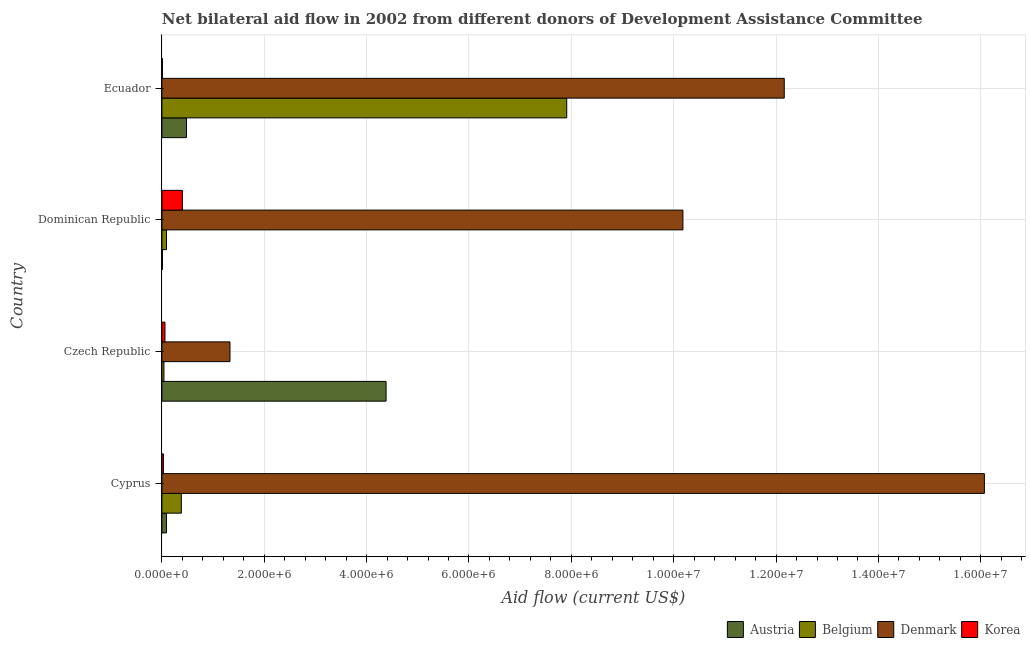How many groups of bars are there?
Provide a succinct answer. 4. Are the number of bars per tick equal to the number of legend labels?
Make the answer very short. Yes. How many bars are there on the 1st tick from the top?
Offer a very short reply. 4. What is the label of the 2nd group of bars from the top?
Make the answer very short. Dominican Republic. In how many cases, is the number of bars for a given country not equal to the number of legend labels?
Ensure brevity in your answer.  0. What is the amount of aid given by korea in Dominican Republic?
Your response must be concise. 4.00e+05. Across all countries, what is the maximum amount of aid given by korea?
Your answer should be very brief. 4.00e+05. Across all countries, what is the minimum amount of aid given by denmark?
Your answer should be compact. 1.33e+06. In which country was the amount of aid given by belgium maximum?
Your answer should be compact. Ecuador. In which country was the amount of aid given by belgium minimum?
Offer a terse response. Czech Republic. What is the total amount of aid given by austria in the graph?
Provide a short and direct response. 4.96e+06. What is the difference between the amount of aid given by korea in Cyprus and that in Czech Republic?
Offer a terse response. -3.00e+04. What is the difference between the amount of aid given by korea in Ecuador and the amount of aid given by austria in Cyprus?
Your answer should be compact. -8.00e+04. What is the average amount of aid given by korea per country?
Ensure brevity in your answer.  1.25e+05. What is the difference between the amount of aid given by korea and amount of aid given by denmark in Czech Republic?
Provide a short and direct response. -1.27e+06. In how many countries, is the amount of aid given by belgium greater than 800000 US$?
Your answer should be compact. 1. What is the ratio of the amount of aid given by denmark in Cyprus to that in Dominican Republic?
Give a very brief answer. 1.58. Is the amount of aid given by denmark in Czech Republic less than that in Dominican Republic?
Give a very brief answer. Yes. Is the difference between the amount of aid given by korea in Dominican Republic and Ecuador greater than the difference between the amount of aid given by denmark in Dominican Republic and Ecuador?
Offer a terse response. Yes. What is the difference between the highest and the second highest amount of aid given by korea?
Your answer should be very brief. 3.40e+05. What is the difference between the highest and the lowest amount of aid given by austria?
Offer a very short reply. 4.37e+06. In how many countries, is the amount of aid given by austria greater than the average amount of aid given by austria taken over all countries?
Make the answer very short. 1. What does the 1st bar from the bottom in Dominican Republic represents?
Your response must be concise. Austria. How many bars are there?
Your response must be concise. 16. How many countries are there in the graph?
Provide a succinct answer. 4. Are the values on the major ticks of X-axis written in scientific E-notation?
Provide a succinct answer. Yes. Does the graph contain grids?
Provide a succinct answer. Yes. How many legend labels are there?
Ensure brevity in your answer.  4. What is the title of the graph?
Your response must be concise. Net bilateral aid flow in 2002 from different donors of Development Assistance Committee. Does "International Development Association" appear as one of the legend labels in the graph?
Your response must be concise. No. What is the Aid flow (current US$) in Austria in Cyprus?
Give a very brief answer. 9.00e+04. What is the Aid flow (current US$) in Denmark in Cyprus?
Your answer should be very brief. 1.61e+07. What is the Aid flow (current US$) in Austria in Czech Republic?
Your answer should be very brief. 4.38e+06. What is the Aid flow (current US$) of Belgium in Czech Republic?
Offer a very short reply. 4.00e+04. What is the Aid flow (current US$) in Denmark in Czech Republic?
Provide a short and direct response. 1.33e+06. What is the Aid flow (current US$) of Belgium in Dominican Republic?
Make the answer very short. 9.00e+04. What is the Aid flow (current US$) of Denmark in Dominican Republic?
Provide a short and direct response. 1.02e+07. What is the Aid flow (current US$) of Korea in Dominican Republic?
Give a very brief answer. 4.00e+05. What is the Aid flow (current US$) of Austria in Ecuador?
Give a very brief answer. 4.80e+05. What is the Aid flow (current US$) in Belgium in Ecuador?
Give a very brief answer. 7.91e+06. What is the Aid flow (current US$) in Denmark in Ecuador?
Offer a very short reply. 1.22e+07. Across all countries, what is the maximum Aid flow (current US$) in Austria?
Your response must be concise. 4.38e+06. Across all countries, what is the maximum Aid flow (current US$) in Belgium?
Provide a succinct answer. 7.91e+06. Across all countries, what is the maximum Aid flow (current US$) in Denmark?
Provide a short and direct response. 1.61e+07. Across all countries, what is the minimum Aid flow (current US$) in Austria?
Your answer should be very brief. 10000. Across all countries, what is the minimum Aid flow (current US$) of Belgium?
Your answer should be very brief. 4.00e+04. Across all countries, what is the minimum Aid flow (current US$) of Denmark?
Provide a short and direct response. 1.33e+06. What is the total Aid flow (current US$) in Austria in the graph?
Your answer should be very brief. 4.96e+06. What is the total Aid flow (current US$) in Belgium in the graph?
Provide a succinct answer. 8.42e+06. What is the total Aid flow (current US$) in Denmark in the graph?
Offer a terse response. 3.97e+07. What is the difference between the Aid flow (current US$) in Austria in Cyprus and that in Czech Republic?
Provide a short and direct response. -4.29e+06. What is the difference between the Aid flow (current US$) of Denmark in Cyprus and that in Czech Republic?
Keep it short and to the point. 1.47e+07. What is the difference between the Aid flow (current US$) of Korea in Cyprus and that in Czech Republic?
Your answer should be compact. -3.00e+04. What is the difference between the Aid flow (current US$) of Belgium in Cyprus and that in Dominican Republic?
Your answer should be very brief. 2.90e+05. What is the difference between the Aid flow (current US$) of Denmark in Cyprus and that in Dominican Republic?
Your response must be concise. 5.89e+06. What is the difference between the Aid flow (current US$) in Korea in Cyprus and that in Dominican Republic?
Give a very brief answer. -3.70e+05. What is the difference between the Aid flow (current US$) of Austria in Cyprus and that in Ecuador?
Offer a very short reply. -3.90e+05. What is the difference between the Aid flow (current US$) of Belgium in Cyprus and that in Ecuador?
Keep it short and to the point. -7.53e+06. What is the difference between the Aid flow (current US$) in Denmark in Cyprus and that in Ecuador?
Give a very brief answer. 3.91e+06. What is the difference between the Aid flow (current US$) in Korea in Cyprus and that in Ecuador?
Keep it short and to the point. 2.00e+04. What is the difference between the Aid flow (current US$) of Austria in Czech Republic and that in Dominican Republic?
Provide a succinct answer. 4.37e+06. What is the difference between the Aid flow (current US$) in Belgium in Czech Republic and that in Dominican Republic?
Provide a short and direct response. -5.00e+04. What is the difference between the Aid flow (current US$) in Denmark in Czech Republic and that in Dominican Republic?
Make the answer very short. -8.85e+06. What is the difference between the Aid flow (current US$) of Korea in Czech Republic and that in Dominican Republic?
Give a very brief answer. -3.40e+05. What is the difference between the Aid flow (current US$) in Austria in Czech Republic and that in Ecuador?
Your answer should be compact. 3.90e+06. What is the difference between the Aid flow (current US$) in Belgium in Czech Republic and that in Ecuador?
Provide a short and direct response. -7.87e+06. What is the difference between the Aid flow (current US$) of Denmark in Czech Republic and that in Ecuador?
Keep it short and to the point. -1.08e+07. What is the difference between the Aid flow (current US$) of Austria in Dominican Republic and that in Ecuador?
Your response must be concise. -4.70e+05. What is the difference between the Aid flow (current US$) of Belgium in Dominican Republic and that in Ecuador?
Your response must be concise. -7.82e+06. What is the difference between the Aid flow (current US$) in Denmark in Dominican Republic and that in Ecuador?
Keep it short and to the point. -1.98e+06. What is the difference between the Aid flow (current US$) in Austria in Cyprus and the Aid flow (current US$) in Denmark in Czech Republic?
Your answer should be very brief. -1.24e+06. What is the difference between the Aid flow (current US$) of Austria in Cyprus and the Aid flow (current US$) of Korea in Czech Republic?
Keep it short and to the point. 3.00e+04. What is the difference between the Aid flow (current US$) in Belgium in Cyprus and the Aid flow (current US$) in Denmark in Czech Republic?
Your answer should be compact. -9.50e+05. What is the difference between the Aid flow (current US$) of Belgium in Cyprus and the Aid flow (current US$) of Korea in Czech Republic?
Your answer should be very brief. 3.20e+05. What is the difference between the Aid flow (current US$) in Denmark in Cyprus and the Aid flow (current US$) in Korea in Czech Republic?
Provide a short and direct response. 1.60e+07. What is the difference between the Aid flow (current US$) in Austria in Cyprus and the Aid flow (current US$) in Belgium in Dominican Republic?
Make the answer very short. 0. What is the difference between the Aid flow (current US$) of Austria in Cyprus and the Aid flow (current US$) of Denmark in Dominican Republic?
Your answer should be very brief. -1.01e+07. What is the difference between the Aid flow (current US$) of Austria in Cyprus and the Aid flow (current US$) of Korea in Dominican Republic?
Offer a very short reply. -3.10e+05. What is the difference between the Aid flow (current US$) of Belgium in Cyprus and the Aid flow (current US$) of Denmark in Dominican Republic?
Ensure brevity in your answer.  -9.80e+06. What is the difference between the Aid flow (current US$) in Denmark in Cyprus and the Aid flow (current US$) in Korea in Dominican Republic?
Give a very brief answer. 1.57e+07. What is the difference between the Aid flow (current US$) of Austria in Cyprus and the Aid flow (current US$) of Belgium in Ecuador?
Provide a short and direct response. -7.82e+06. What is the difference between the Aid flow (current US$) in Austria in Cyprus and the Aid flow (current US$) in Denmark in Ecuador?
Ensure brevity in your answer.  -1.21e+07. What is the difference between the Aid flow (current US$) in Austria in Cyprus and the Aid flow (current US$) in Korea in Ecuador?
Ensure brevity in your answer.  8.00e+04. What is the difference between the Aid flow (current US$) in Belgium in Cyprus and the Aid flow (current US$) in Denmark in Ecuador?
Give a very brief answer. -1.18e+07. What is the difference between the Aid flow (current US$) of Belgium in Cyprus and the Aid flow (current US$) of Korea in Ecuador?
Offer a terse response. 3.70e+05. What is the difference between the Aid flow (current US$) in Denmark in Cyprus and the Aid flow (current US$) in Korea in Ecuador?
Provide a succinct answer. 1.61e+07. What is the difference between the Aid flow (current US$) of Austria in Czech Republic and the Aid flow (current US$) of Belgium in Dominican Republic?
Your response must be concise. 4.29e+06. What is the difference between the Aid flow (current US$) in Austria in Czech Republic and the Aid flow (current US$) in Denmark in Dominican Republic?
Give a very brief answer. -5.80e+06. What is the difference between the Aid flow (current US$) of Austria in Czech Republic and the Aid flow (current US$) of Korea in Dominican Republic?
Provide a short and direct response. 3.98e+06. What is the difference between the Aid flow (current US$) of Belgium in Czech Republic and the Aid flow (current US$) of Denmark in Dominican Republic?
Make the answer very short. -1.01e+07. What is the difference between the Aid flow (current US$) of Belgium in Czech Republic and the Aid flow (current US$) of Korea in Dominican Republic?
Offer a very short reply. -3.60e+05. What is the difference between the Aid flow (current US$) of Denmark in Czech Republic and the Aid flow (current US$) of Korea in Dominican Republic?
Your answer should be compact. 9.30e+05. What is the difference between the Aid flow (current US$) in Austria in Czech Republic and the Aid flow (current US$) in Belgium in Ecuador?
Offer a terse response. -3.53e+06. What is the difference between the Aid flow (current US$) in Austria in Czech Republic and the Aid flow (current US$) in Denmark in Ecuador?
Your answer should be very brief. -7.78e+06. What is the difference between the Aid flow (current US$) of Austria in Czech Republic and the Aid flow (current US$) of Korea in Ecuador?
Your answer should be compact. 4.37e+06. What is the difference between the Aid flow (current US$) of Belgium in Czech Republic and the Aid flow (current US$) of Denmark in Ecuador?
Provide a short and direct response. -1.21e+07. What is the difference between the Aid flow (current US$) of Denmark in Czech Republic and the Aid flow (current US$) of Korea in Ecuador?
Offer a terse response. 1.32e+06. What is the difference between the Aid flow (current US$) of Austria in Dominican Republic and the Aid flow (current US$) of Belgium in Ecuador?
Offer a terse response. -7.90e+06. What is the difference between the Aid flow (current US$) of Austria in Dominican Republic and the Aid flow (current US$) of Denmark in Ecuador?
Your response must be concise. -1.22e+07. What is the difference between the Aid flow (current US$) of Belgium in Dominican Republic and the Aid flow (current US$) of Denmark in Ecuador?
Your response must be concise. -1.21e+07. What is the difference between the Aid flow (current US$) in Denmark in Dominican Republic and the Aid flow (current US$) in Korea in Ecuador?
Give a very brief answer. 1.02e+07. What is the average Aid flow (current US$) in Austria per country?
Provide a succinct answer. 1.24e+06. What is the average Aid flow (current US$) of Belgium per country?
Provide a succinct answer. 2.10e+06. What is the average Aid flow (current US$) in Denmark per country?
Offer a very short reply. 9.94e+06. What is the average Aid flow (current US$) of Korea per country?
Provide a short and direct response. 1.25e+05. What is the difference between the Aid flow (current US$) of Austria and Aid flow (current US$) of Belgium in Cyprus?
Your answer should be very brief. -2.90e+05. What is the difference between the Aid flow (current US$) of Austria and Aid flow (current US$) of Denmark in Cyprus?
Offer a very short reply. -1.60e+07. What is the difference between the Aid flow (current US$) in Austria and Aid flow (current US$) in Korea in Cyprus?
Provide a short and direct response. 6.00e+04. What is the difference between the Aid flow (current US$) of Belgium and Aid flow (current US$) of Denmark in Cyprus?
Keep it short and to the point. -1.57e+07. What is the difference between the Aid flow (current US$) of Belgium and Aid flow (current US$) of Korea in Cyprus?
Your answer should be compact. 3.50e+05. What is the difference between the Aid flow (current US$) of Denmark and Aid flow (current US$) of Korea in Cyprus?
Offer a terse response. 1.60e+07. What is the difference between the Aid flow (current US$) in Austria and Aid flow (current US$) in Belgium in Czech Republic?
Your response must be concise. 4.34e+06. What is the difference between the Aid flow (current US$) of Austria and Aid flow (current US$) of Denmark in Czech Republic?
Offer a very short reply. 3.05e+06. What is the difference between the Aid flow (current US$) of Austria and Aid flow (current US$) of Korea in Czech Republic?
Give a very brief answer. 4.32e+06. What is the difference between the Aid flow (current US$) in Belgium and Aid flow (current US$) in Denmark in Czech Republic?
Provide a succinct answer. -1.29e+06. What is the difference between the Aid flow (current US$) in Denmark and Aid flow (current US$) in Korea in Czech Republic?
Provide a short and direct response. 1.27e+06. What is the difference between the Aid flow (current US$) in Austria and Aid flow (current US$) in Denmark in Dominican Republic?
Your response must be concise. -1.02e+07. What is the difference between the Aid flow (current US$) of Austria and Aid flow (current US$) of Korea in Dominican Republic?
Offer a very short reply. -3.90e+05. What is the difference between the Aid flow (current US$) in Belgium and Aid flow (current US$) in Denmark in Dominican Republic?
Your response must be concise. -1.01e+07. What is the difference between the Aid flow (current US$) in Belgium and Aid flow (current US$) in Korea in Dominican Republic?
Ensure brevity in your answer.  -3.10e+05. What is the difference between the Aid flow (current US$) of Denmark and Aid flow (current US$) of Korea in Dominican Republic?
Provide a short and direct response. 9.78e+06. What is the difference between the Aid flow (current US$) of Austria and Aid flow (current US$) of Belgium in Ecuador?
Offer a very short reply. -7.43e+06. What is the difference between the Aid flow (current US$) of Austria and Aid flow (current US$) of Denmark in Ecuador?
Give a very brief answer. -1.17e+07. What is the difference between the Aid flow (current US$) in Austria and Aid flow (current US$) in Korea in Ecuador?
Make the answer very short. 4.70e+05. What is the difference between the Aid flow (current US$) in Belgium and Aid flow (current US$) in Denmark in Ecuador?
Provide a succinct answer. -4.25e+06. What is the difference between the Aid flow (current US$) of Belgium and Aid flow (current US$) of Korea in Ecuador?
Ensure brevity in your answer.  7.90e+06. What is the difference between the Aid flow (current US$) of Denmark and Aid flow (current US$) of Korea in Ecuador?
Offer a terse response. 1.22e+07. What is the ratio of the Aid flow (current US$) in Austria in Cyprus to that in Czech Republic?
Your answer should be compact. 0.02. What is the ratio of the Aid flow (current US$) in Belgium in Cyprus to that in Czech Republic?
Provide a succinct answer. 9.5. What is the ratio of the Aid flow (current US$) of Denmark in Cyprus to that in Czech Republic?
Ensure brevity in your answer.  12.08. What is the ratio of the Aid flow (current US$) of Korea in Cyprus to that in Czech Republic?
Offer a terse response. 0.5. What is the ratio of the Aid flow (current US$) of Belgium in Cyprus to that in Dominican Republic?
Provide a short and direct response. 4.22. What is the ratio of the Aid flow (current US$) in Denmark in Cyprus to that in Dominican Republic?
Provide a short and direct response. 1.58. What is the ratio of the Aid flow (current US$) in Korea in Cyprus to that in Dominican Republic?
Your answer should be compact. 0.07. What is the ratio of the Aid flow (current US$) of Austria in Cyprus to that in Ecuador?
Keep it short and to the point. 0.19. What is the ratio of the Aid flow (current US$) in Belgium in Cyprus to that in Ecuador?
Ensure brevity in your answer.  0.05. What is the ratio of the Aid flow (current US$) of Denmark in Cyprus to that in Ecuador?
Offer a very short reply. 1.32. What is the ratio of the Aid flow (current US$) of Korea in Cyprus to that in Ecuador?
Provide a succinct answer. 3. What is the ratio of the Aid flow (current US$) in Austria in Czech Republic to that in Dominican Republic?
Your answer should be very brief. 438. What is the ratio of the Aid flow (current US$) in Belgium in Czech Republic to that in Dominican Republic?
Provide a short and direct response. 0.44. What is the ratio of the Aid flow (current US$) in Denmark in Czech Republic to that in Dominican Republic?
Your answer should be very brief. 0.13. What is the ratio of the Aid flow (current US$) in Austria in Czech Republic to that in Ecuador?
Ensure brevity in your answer.  9.12. What is the ratio of the Aid flow (current US$) in Belgium in Czech Republic to that in Ecuador?
Offer a terse response. 0.01. What is the ratio of the Aid flow (current US$) in Denmark in Czech Republic to that in Ecuador?
Give a very brief answer. 0.11. What is the ratio of the Aid flow (current US$) in Austria in Dominican Republic to that in Ecuador?
Offer a very short reply. 0.02. What is the ratio of the Aid flow (current US$) of Belgium in Dominican Republic to that in Ecuador?
Your answer should be very brief. 0.01. What is the ratio of the Aid flow (current US$) in Denmark in Dominican Republic to that in Ecuador?
Keep it short and to the point. 0.84. What is the ratio of the Aid flow (current US$) of Korea in Dominican Republic to that in Ecuador?
Keep it short and to the point. 40. What is the difference between the highest and the second highest Aid flow (current US$) in Austria?
Give a very brief answer. 3.90e+06. What is the difference between the highest and the second highest Aid flow (current US$) of Belgium?
Your answer should be compact. 7.53e+06. What is the difference between the highest and the second highest Aid flow (current US$) in Denmark?
Ensure brevity in your answer.  3.91e+06. What is the difference between the highest and the lowest Aid flow (current US$) of Austria?
Ensure brevity in your answer.  4.37e+06. What is the difference between the highest and the lowest Aid flow (current US$) of Belgium?
Offer a terse response. 7.87e+06. What is the difference between the highest and the lowest Aid flow (current US$) of Denmark?
Provide a succinct answer. 1.47e+07. 